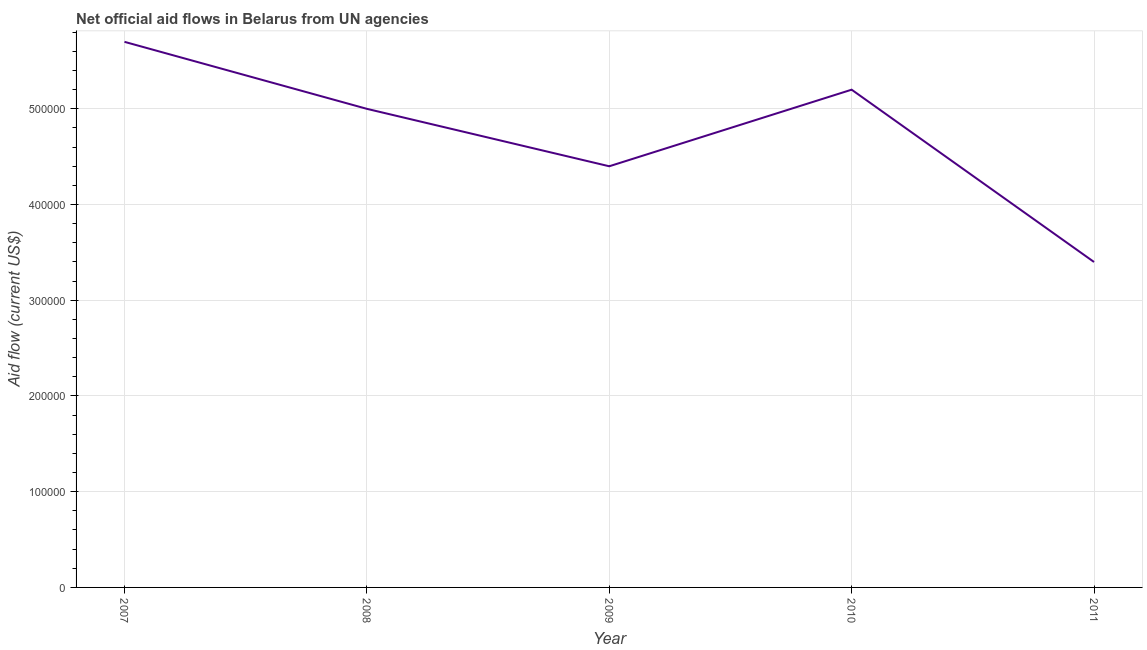What is the net official flows from un agencies in 2011?
Make the answer very short. 3.40e+05. Across all years, what is the maximum net official flows from un agencies?
Provide a succinct answer. 5.70e+05. Across all years, what is the minimum net official flows from un agencies?
Make the answer very short. 3.40e+05. In which year was the net official flows from un agencies maximum?
Your answer should be compact. 2007. In which year was the net official flows from un agencies minimum?
Provide a succinct answer. 2011. What is the sum of the net official flows from un agencies?
Keep it short and to the point. 2.37e+06. What is the difference between the net official flows from un agencies in 2008 and 2011?
Ensure brevity in your answer.  1.60e+05. What is the average net official flows from un agencies per year?
Keep it short and to the point. 4.74e+05. What is the median net official flows from un agencies?
Your answer should be very brief. 5.00e+05. In how many years, is the net official flows from un agencies greater than 480000 US$?
Provide a succinct answer. 3. Do a majority of the years between 2009 and 2011 (inclusive) have net official flows from un agencies greater than 560000 US$?
Make the answer very short. No. What is the ratio of the net official flows from un agencies in 2008 to that in 2011?
Offer a terse response. 1.47. Is the net official flows from un agencies in 2010 less than that in 2011?
Offer a very short reply. No. Is the difference between the net official flows from un agencies in 2010 and 2011 greater than the difference between any two years?
Provide a short and direct response. No. What is the difference between the highest and the second highest net official flows from un agencies?
Your answer should be compact. 5.00e+04. Is the sum of the net official flows from un agencies in 2009 and 2010 greater than the maximum net official flows from un agencies across all years?
Give a very brief answer. Yes. What is the difference between the highest and the lowest net official flows from un agencies?
Provide a short and direct response. 2.30e+05. How many lines are there?
Offer a terse response. 1. How many years are there in the graph?
Provide a short and direct response. 5. Are the values on the major ticks of Y-axis written in scientific E-notation?
Offer a terse response. No. Does the graph contain any zero values?
Make the answer very short. No. What is the title of the graph?
Offer a terse response. Net official aid flows in Belarus from UN agencies. What is the label or title of the X-axis?
Offer a terse response. Year. What is the label or title of the Y-axis?
Give a very brief answer. Aid flow (current US$). What is the Aid flow (current US$) in 2007?
Provide a succinct answer. 5.70e+05. What is the Aid flow (current US$) of 2010?
Your answer should be compact. 5.20e+05. What is the difference between the Aid flow (current US$) in 2007 and 2010?
Make the answer very short. 5.00e+04. What is the difference between the Aid flow (current US$) in 2008 and 2011?
Offer a very short reply. 1.60e+05. What is the difference between the Aid flow (current US$) in 2009 and 2010?
Your answer should be compact. -8.00e+04. What is the ratio of the Aid flow (current US$) in 2007 to that in 2008?
Make the answer very short. 1.14. What is the ratio of the Aid flow (current US$) in 2007 to that in 2009?
Your response must be concise. 1.29. What is the ratio of the Aid flow (current US$) in 2007 to that in 2010?
Provide a succinct answer. 1.1. What is the ratio of the Aid flow (current US$) in 2007 to that in 2011?
Offer a terse response. 1.68. What is the ratio of the Aid flow (current US$) in 2008 to that in 2009?
Give a very brief answer. 1.14. What is the ratio of the Aid flow (current US$) in 2008 to that in 2010?
Ensure brevity in your answer.  0.96. What is the ratio of the Aid flow (current US$) in 2008 to that in 2011?
Keep it short and to the point. 1.47. What is the ratio of the Aid flow (current US$) in 2009 to that in 2010?
Your answer should be compact. 0.85. What is the ratio of the Aid flow (current US$) in 2009 to that in 2011?
Keep it short and to the point. 1.29. What is the ratio of the Aid flow (current US$) in 2010 to that in 2011?
Your answer should be very brief. 1.53. 